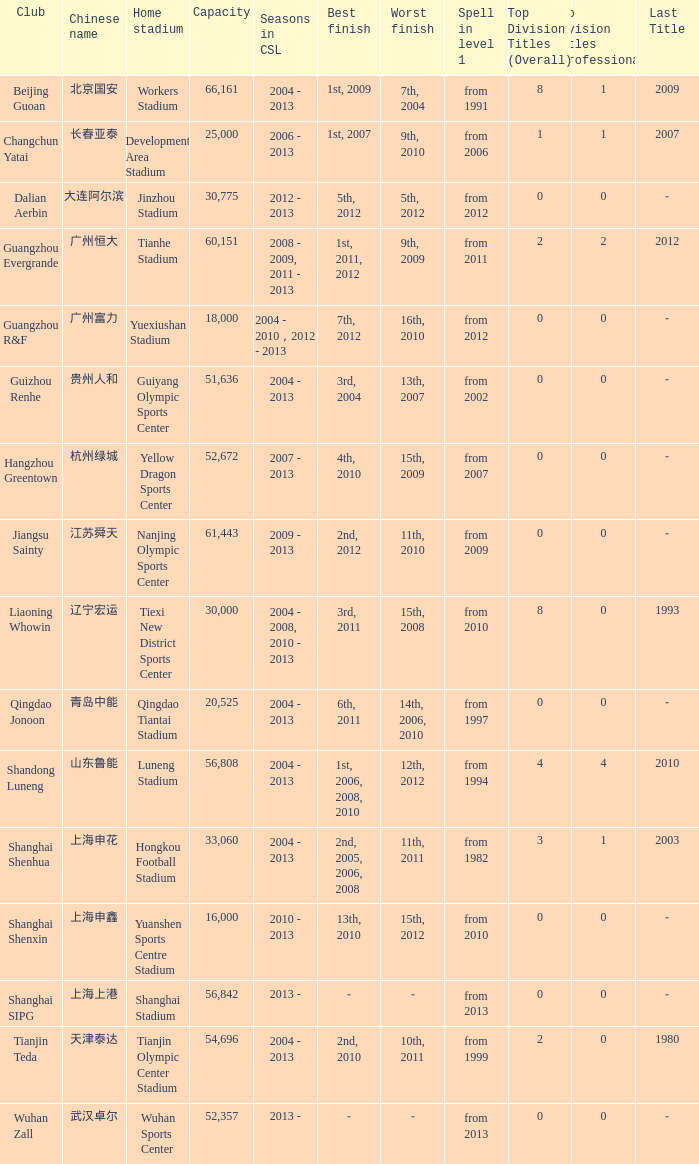What were the years for Seasons in CSL when they played in the Guiyang Olympic Sports Center and had Top Division Titles (Overall) of 0? 2004 - 2013. 